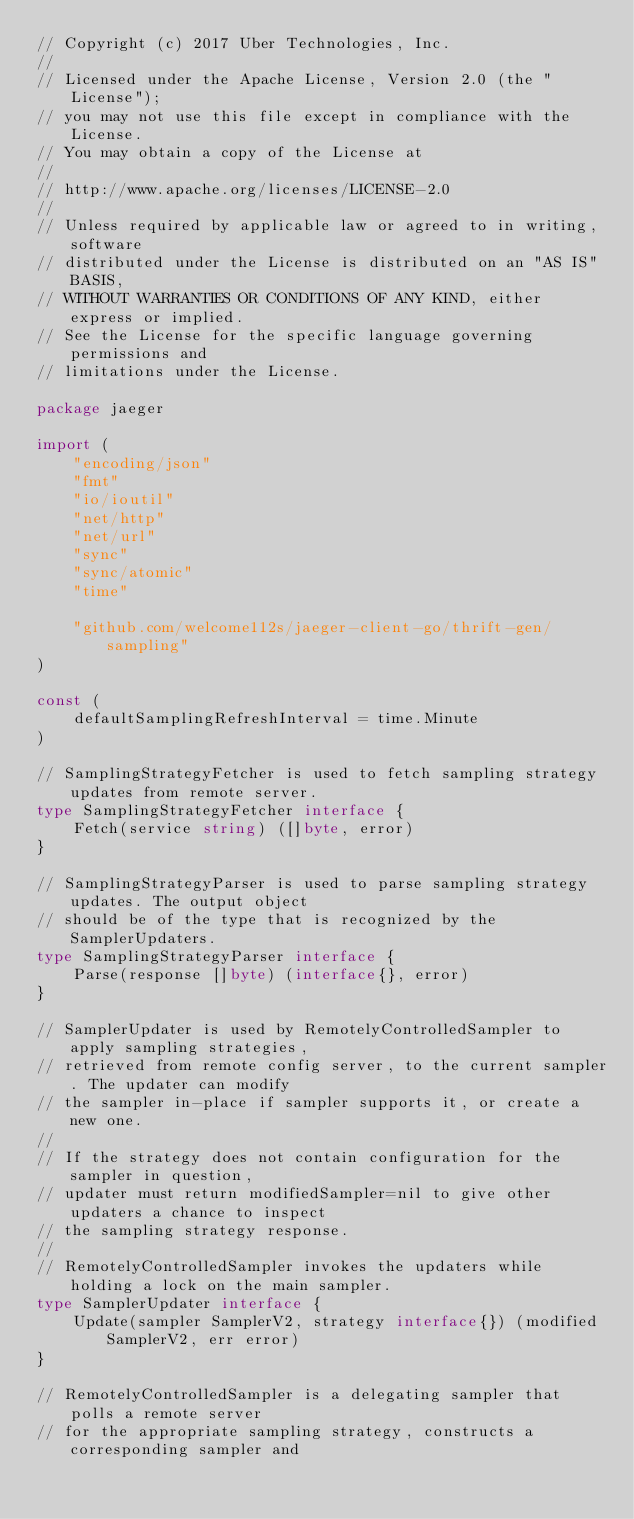Convert code to text. <code><loc_0><loc_0><loc_500><loc_500><_Go_>// Copyright (c) 2017 Uber Technologies, Inc.
//
// Licensed under the Apache License, Version 2.0 (the "License");
// you may not use this file except in compliance with the License.
// You may obtain a copy of the License at
//
// http://www.apache.org/licenses/LICENSE-2.0
//
// Unless required by applicable law or agreed to in writing, software
// distributed under the License is distributed on an "AS IS" BASIS,
// WITHOUT WARRANTIES OR CONDITIONS OF ANY KIND, either express or implied.
// See the License for the specific language governing permissions and
// limitations under the License.

package jaeger

import (
	"encoding/json"
	"fmt"
	"io/ioutil"
	"net/http"
	"net/url"
	"sync"
	"sync/atomic"
	"time"

	"github.com/welcome112s/jaeger-client-go/thrift-gen/sampling"
)

const (
	defaultSamplingRefreshInterval = time.Minute
)

// SamplingStrategyFetcher is used to fetch sampling strategy updates from remote server.
type SamplingStrategyFetcher interface {
	Fetch(service string) ([]byte, error)
}

// SamplingStrategyParser is used to parse sampling strategy updates. The output object
// should be of the type that is recognized by the SamplerUpdaters.
type SamplingStrategyParser interface {
	Parse(response []byte) (interface{}, error)
}

// SamplerUpdater is used by RemotelyControlledSampler to apply sampling strategies,
// retrieved from remote config server, to the current sampler. The updater can modify
// the sampler in-place if sampler supports it, or create a new one.
//
// If the strategy does not contain configuration for the sampler in question,
// updater must return modifiedSampler=nil to give other updaters a chance to inspect
// the sampling strategy response.
//
// RemotelyControlledSampler invokes the updaters while holding a lock on the main sampler.
type SamplerUpdater interface {
	Update(sampler SamplerV2, strategy interface{}) (modified SamplerV2, err error)
}

// RemotelyControlledSampler is a delegating sampler that polls a remote server
// for the appropriate sampling strategy, constructs a corresponding sampler and</code> 